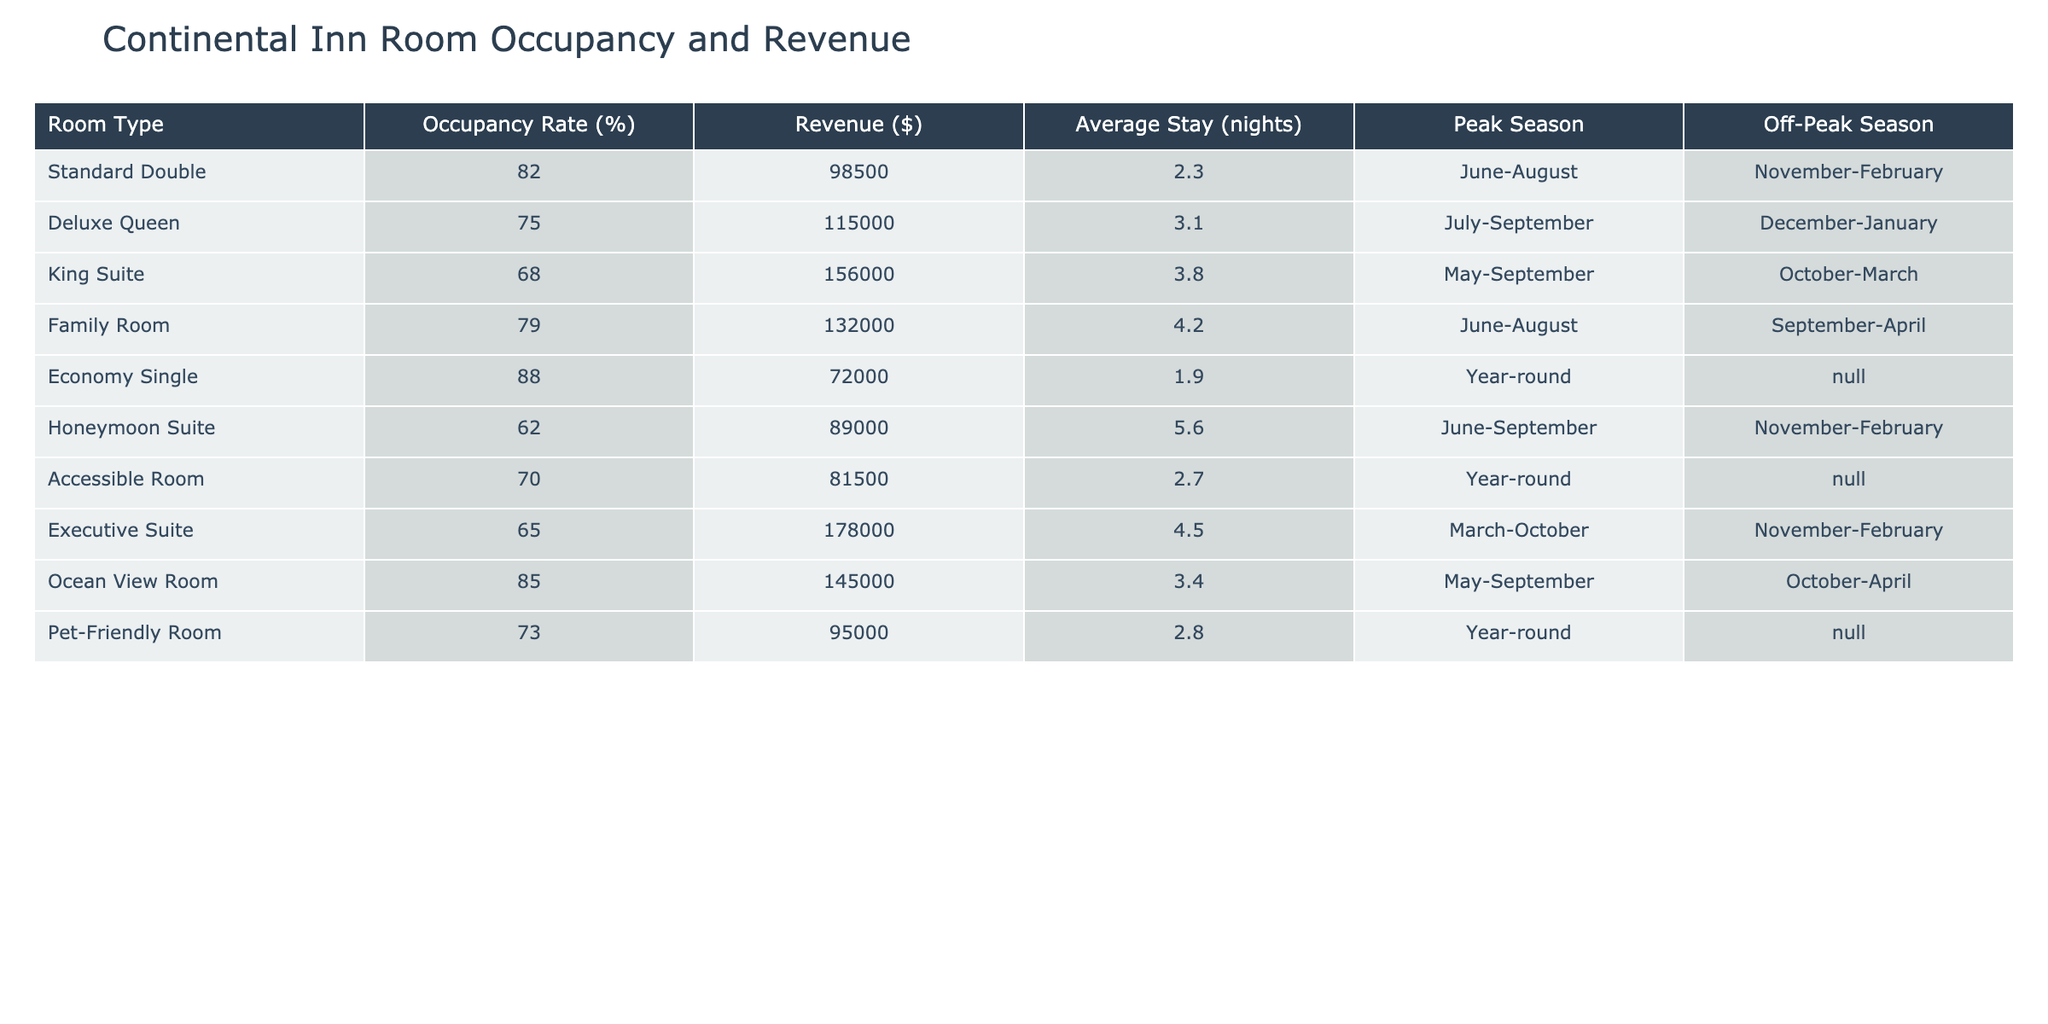What is the revenue generated by the Deluxe Queen room type? From the table, the revenue listed under the Deluxe Queen category is $115,000.
Answer: $115,000 Which room type has the highest occupancy rate? The occupancy rates are compared: Standard Double (82%), Economy Single (88%), King Suite (68%), Family Room (79%), Deluxe Queen (75%), Honeymoon Suite (62%), Accessible Room (70%), Executive Suite (65%), Ocean View Room (85%), and Pet-Friendly Room (73%). The Economy Single room has the highest rate at 88%.
Answer: Economy Single Is the occupancy rate of the King Suite higher than that of the Honeymoon Suite? The King Suite has an occupancy rate of 68%, while the Honeymoon Suite has 62%. Since 68% is greater than 62%, the King Suite's rate is indeed higher.
Answer: Yes What is the average stay duration for the Executive Suite? The average stay duration for the Executive Suite is specified in the table as 4.5 nights.
Answer: 4.5 nights Which room types have a revenue of over $100,000? Analyzing the revenue for each room type: Standard Double ($98,500), Deluxe Queen ($115,000), King Suite ($156,000), Family Room ($132,000), Economy Single ($72,000), Honeymoon Suite ($89,000), Accessible Room ($81,500), Executive Suite ($178,000), Ocean View Room ($145,000), Pet-Friendly Room ($95,000). The room types with revenue over $100,000 are Deluxe Queen, King Suite, Family Room, Executive Suite, and Ocean View Room.
Answer: Deluxe Queen, King Suite, Family Room, Executive Suite, Ocean View Room What is the total revenue generated by Standard Double and Family Room combined? The revenue for Standard Double is $98,500 and for Family Room, it's $132,000. Adding these two together gives $98,500 + $132,000 = $230,500.
Answer: $230,500 Which room type has the longest average stay? The average stay for each room type is listed as follows: Standard Double (2.3 nights), Deluxe Queen (3.1), King Suite (3.8), Family Room (4.2), Economy Single (1.9), Honeymoon Suite (5.6), Accessible Room (2.7), Executive Suite (4.5), Ocean View Room (3.4), Pet-Friendly Room (2.8). The longest stay is for the Honeymoon Suite at 5.6 nights.
Answer: Honeymoon Suite Is the Accessible Room revenue higher than that of the Pet-Friendly Room? The Accessible Room generates $81,500 in revenue while the Pet-Friendly Room generates $95,000. Since $81,500 is less than $95,000, the Accessible Room does not have higher revenue.
Answer: No What is the average occupancy rate of the rooms listed? To find the average occupancy rate, sum up the occupancy rates: 82 + 75 + 68 + 79 + 88 + 62 + 70 + 65 + 85 + 73 =  77.7; then divide by the number of room types (10): 777 / 10 = 77.7%.
Answer: 77.7% Which room types are available year-round? The table indicates that the Economy Single, Accessible Room, and Pet-Friendly Room are available year-round.
Answer: Economy Single, Accessible Room, Pet-Friendly Room Are there any room types with an occupancy rate lower than 70%? Reviewing the occupancy rates: King Suite (68%), Honeymoon Suite (62%), and Executive Suite (65%) all have rates below 70%. Therefore, there are room types with occupancy rates lower than 70%.
Answer: Yes 